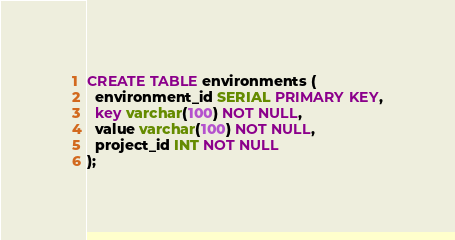<code> <loc_0><loc_0><loc_500><loc_500><_SQL_>CREATE TABLE environments (
  environment_id SERIAL PRIMARY KEY,
  key varchar(100) NOT NULL,
  value varchar(100) NOT NULL,
  project_id INT NOT NULL
);</code> 